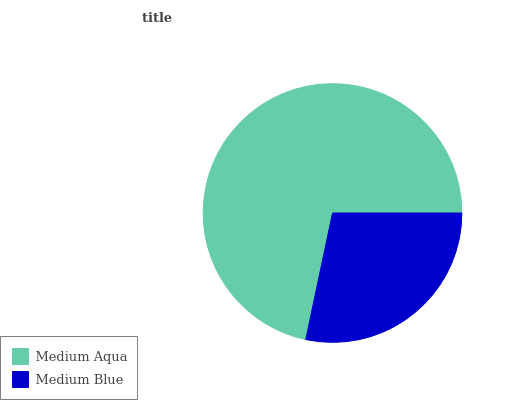Is Medium Blue the minimum?
Answer yes or no. Yes. Is Medium Aqua the maximum?
Answer yes or no. Yes. Is Medium Blue the maximum?
Answer yes or no. No. Is Medium Aqua greater than Medium Blue?
Answer yes or no. Yes. Is Medium Blue less than Medium Aqua?
Answer yes or no. Yes. Is Medium Blue greater than Medium Aqua?
Answer yes or no. No. Is Medium Aqua less than Medium Blue?
Answer yes or no. No. Is Medium Aqua the high median?
Answer yes or no. Yes. Is Medium Blue the low median?
Answer yes or no. Yes. Is Medium Blue the high median?
Answer yes or no. No. Is Medium Aqua the low median?
Answer yes or no. No. 